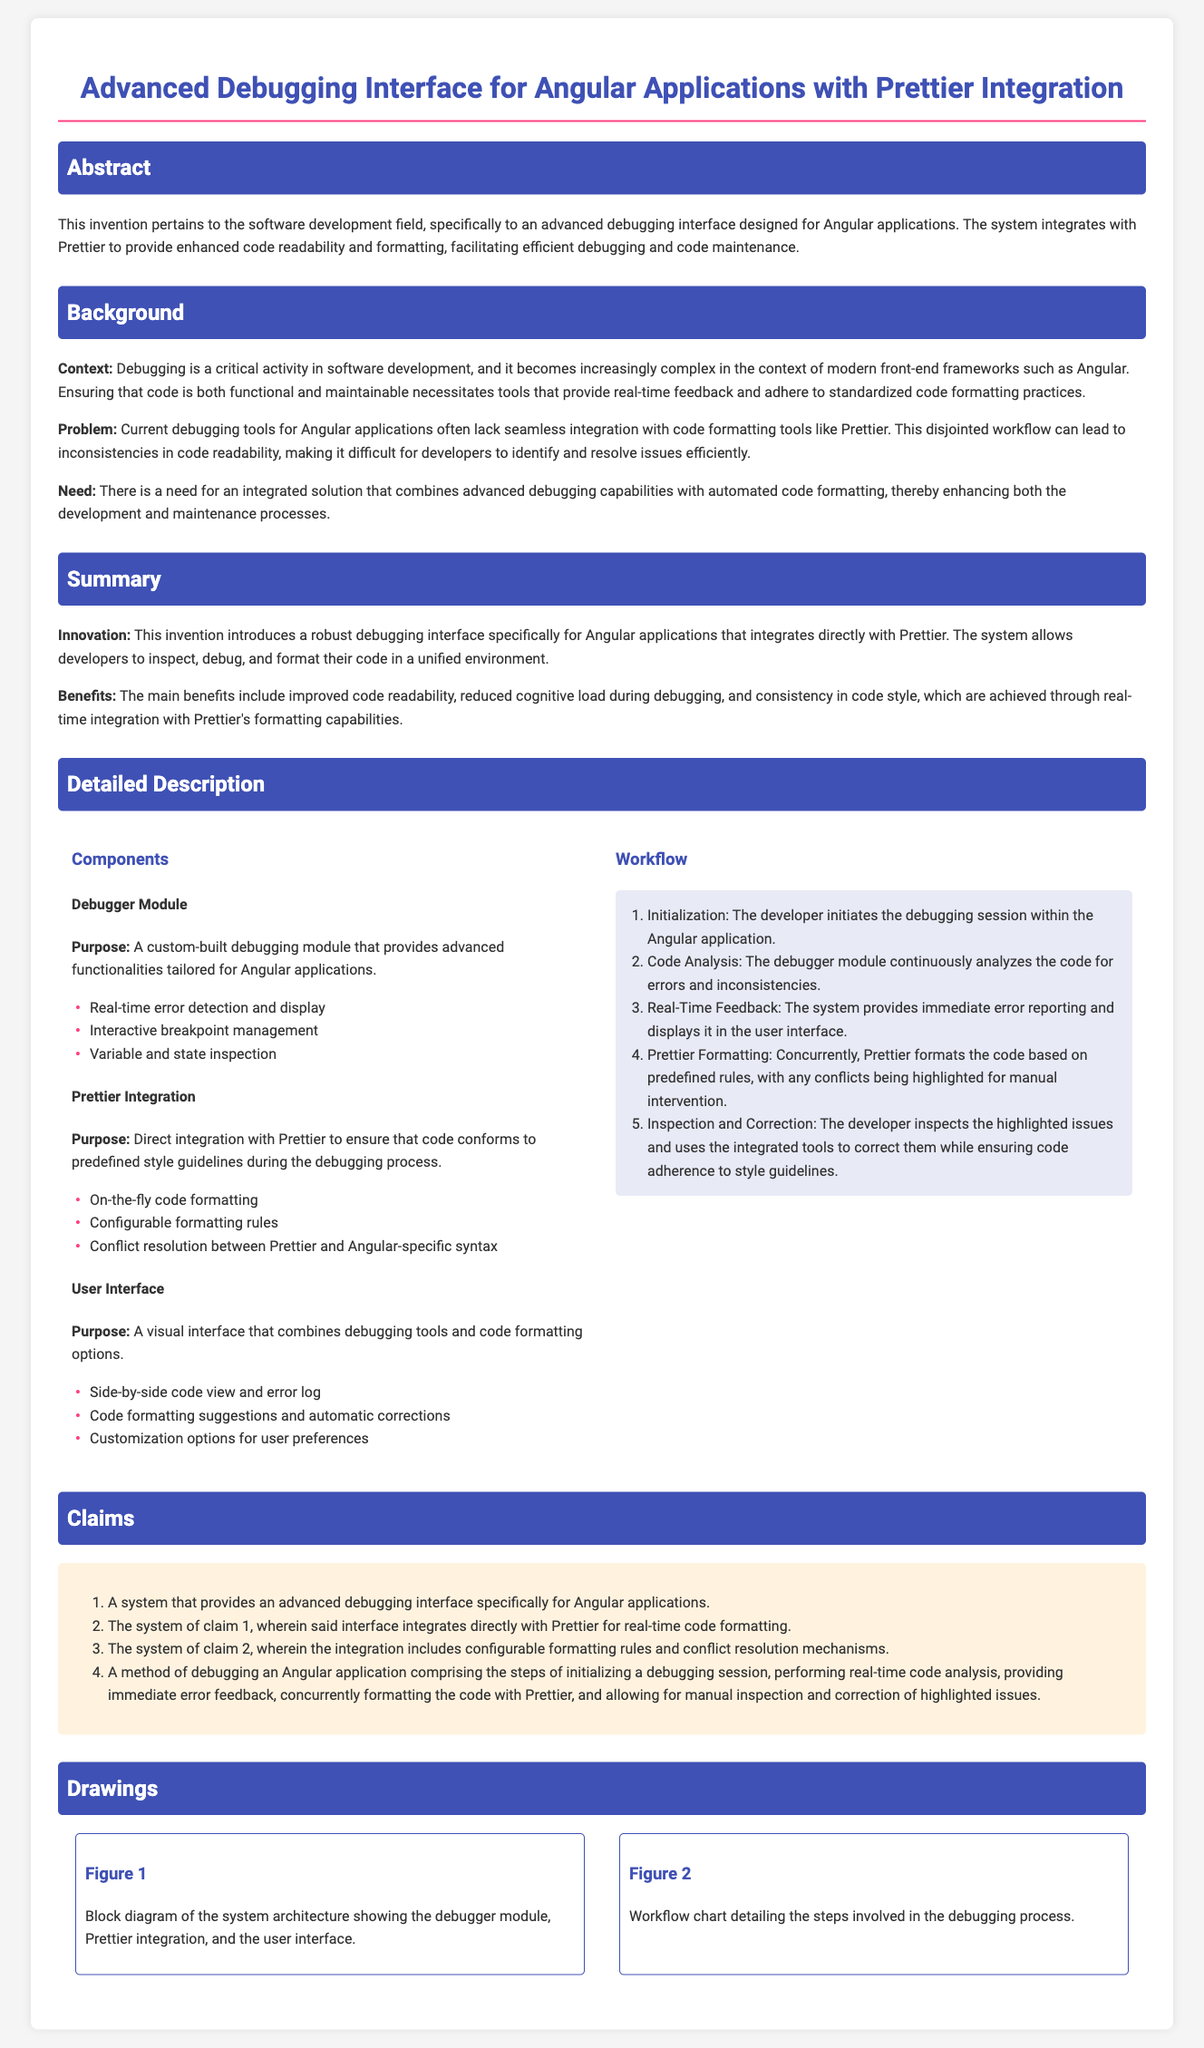What is the title of the patent application? The title clearly states the subject of the patent application.
Answer: Advanced Debugging Interface for Angular Applications with Prettier Integration What is the purpose of the debugger module? The purpose of the debugger module is defined in the components section.
Answer: Advanced functionalities tailored for Angular applications What are the main benefits of this invention? The summary section highlights the benefits of the invention.
Answer: Improved code readability, reduced cognitive load during debugging, and consistency in code style How many claims are presented in the document? The claims section lists a number of claims that define the scope of the invention.
Answer: Four claims What step follows real-time feedback in the workflow? The workflow section outlines the steps involved in the debugging process.
Answer: Prettier Formatting What does the term "workflow" refer to in this document? The document describes workflow in the context of debugging processes used in Angular applications.
Answer: The steps involved in the debugging process What is integrated with the debugging interface to enhance code readability? The integration section specifies components that enhance code readability during debugging.
Answer: Prettier What is the context of the invention stated in the background? The background section provides foundational information on the relevance of the invention.
Answer: Debugging is a critical activity in software development What does Figure 1 represent in the drawings section? The drawings section describes the purpose of the included figures.
Answer: Block diagram of the system architecture 